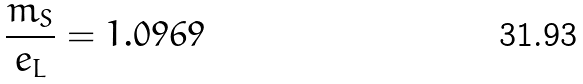Convert formula to latex. <formula><loc_0><loc_0><loc_500><loc_500>\frac { m _ { S } } { e _ { L } } = 1 . 0 9 6 9</formula> 